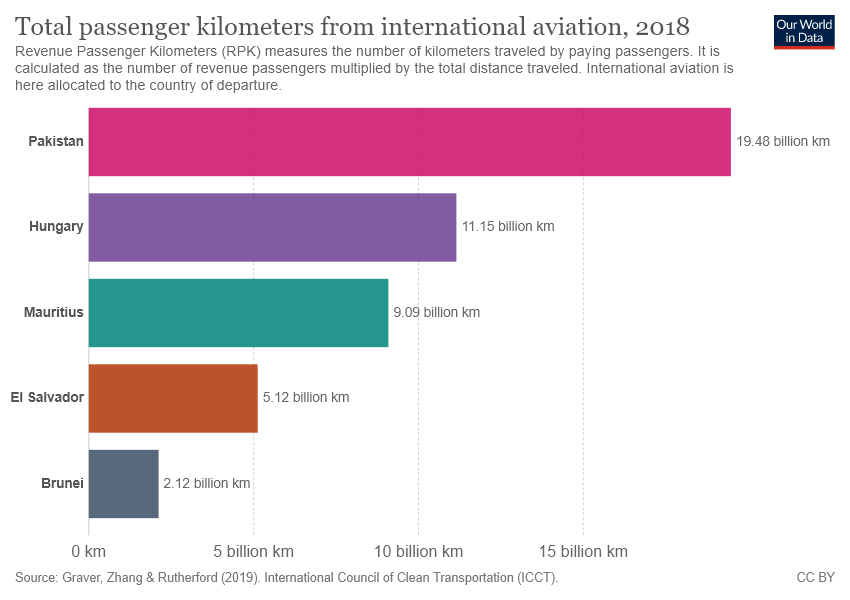Identify some key points in this picture. Five colors are represented in the bar. The largest bar has a measurement of 17.36, while the smallest bar has a measurement of 17.36. 